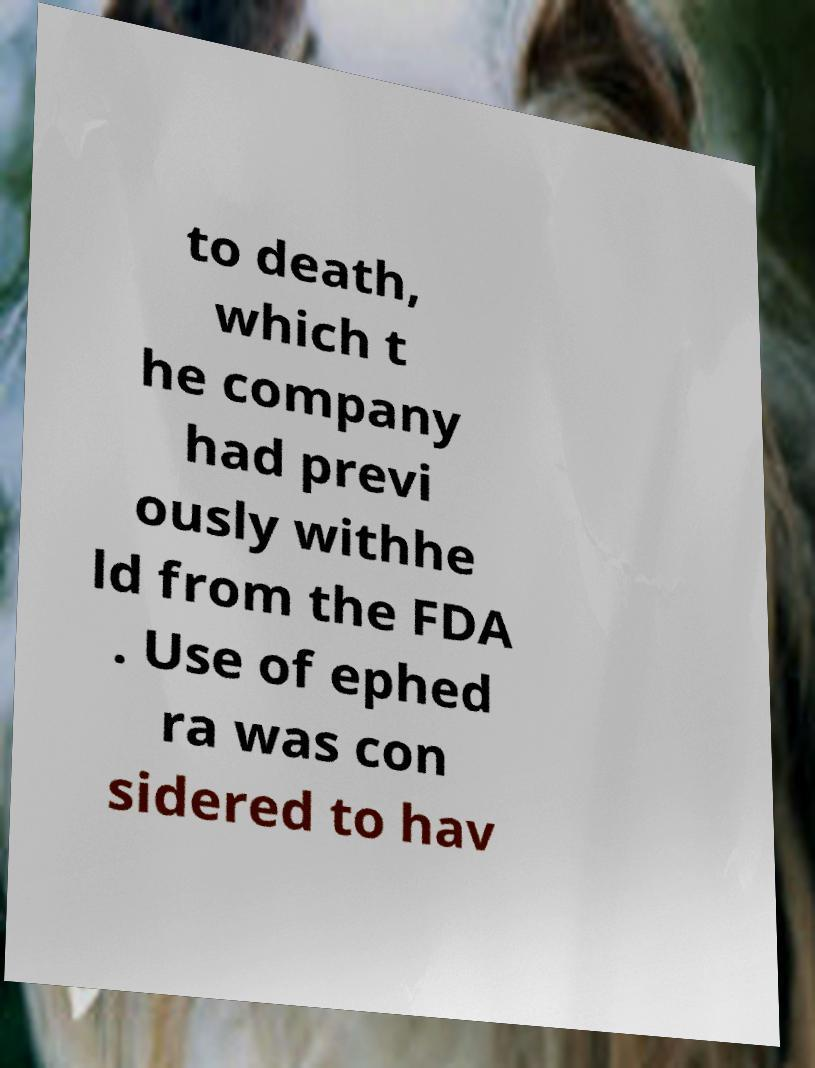Can you read and provide the text displayed in the image?This photo seems to have some interesting text. Can you extract and type it out for me? to death, which t he company had previ ously withhe ld from the FDA . Use of ephed ra was con sidered to hav 